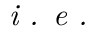Convert formula to latex. <formula><loc_0><loc_0><loc_500><loc_500>i . e .</formula> 